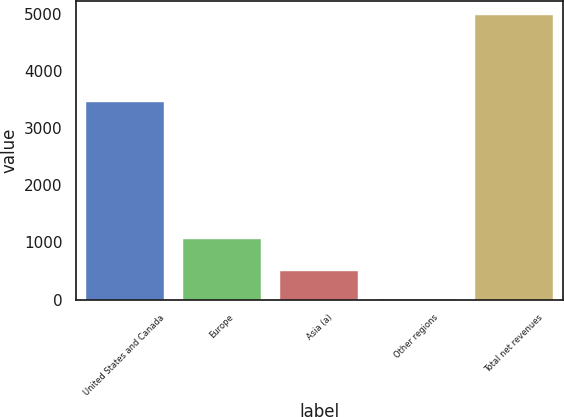Convert chart to OTSL. <chart><loc_0><loc_0><loc_500><loc_500><bar_chart><fcel>United States and Canada<fcel>Europe<fcel>Asia (a)<fcel>Other regions<fcel>Total net revenues<nl><fcel>3462.3<fcel>1052.6<fcel>501.76<fcel>4.3<fcel>4978.9<nl></chart> 